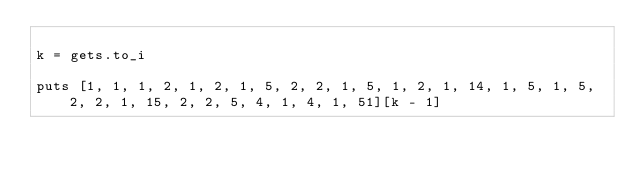Convert code to text. <code><loc_0><loc_0><loc_500><loc_500><_Ruby_>
k = gets.to_i

puts [1, 1, 1, 2, 1, 2, 1, 5, 2, 2, 1, 5, 1, 2, 1, 14, 1, 5, 1, 5, 2, 2, 1, 15, 2, 2, 5, 4, 1, 4, 1, 51][k - 1]
</code> 